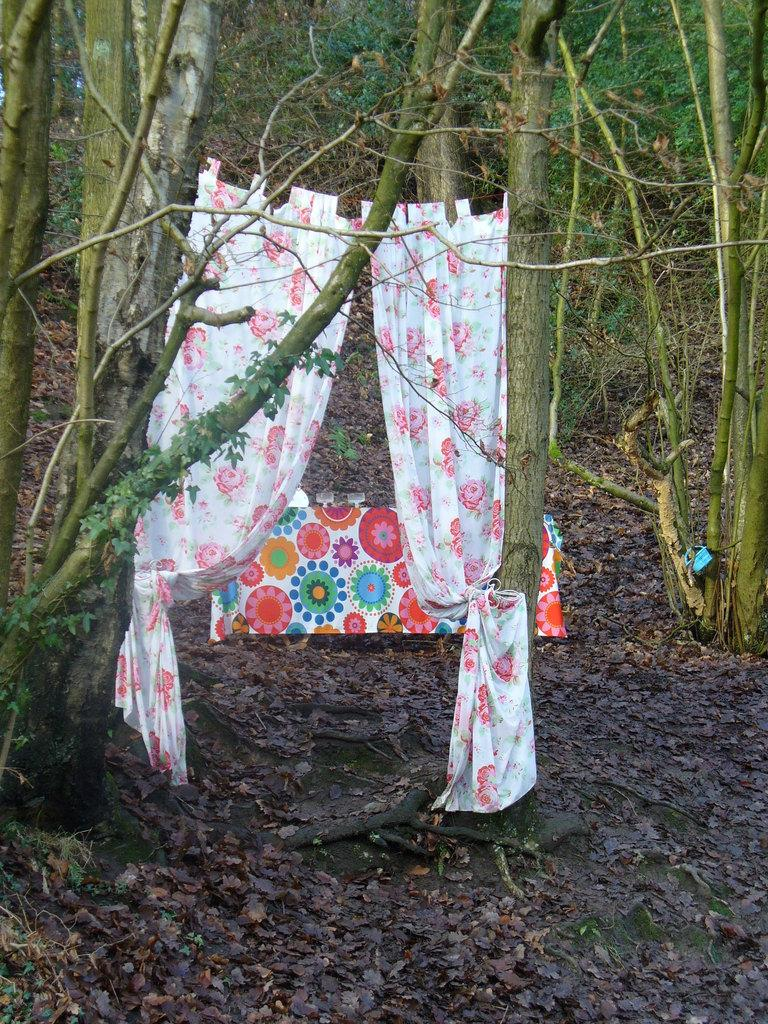What type of natural elements can be seen in the image? There are trees in the image. What type of window treatment is visible in the image? There are curtains in the image. What stands out in terms of color in the image? There is a colorful object in the image. What part of the trees can be seen in the image? Leaves are present in the image. How is the beggar positioned in relation to the colorful object in the image? There is no beggar present in the image. What type of curve can be seen in the distribution of leaves in the image? There is no distribution of leaves mentioned in the facts, and the image does not show any curves related to leaves. 